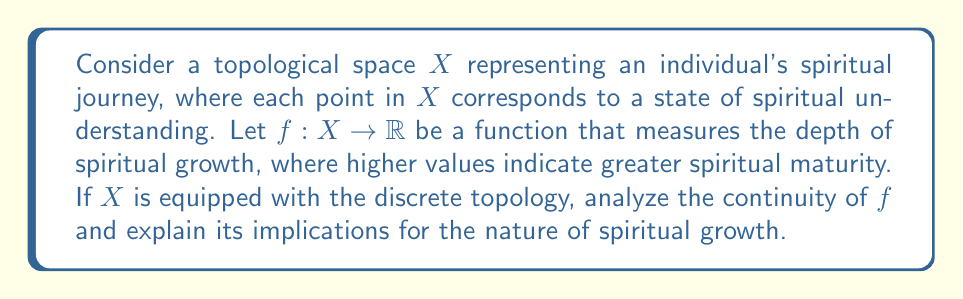Provide a solution to this math problem. To analyze this problem, let's break it down into steps:

1) First, recall that in a discrete topology, every subset of $X$ is open. This means that for any point $x \in X$, the set $\{x\}$ is open.

2) For a function to be continuous in the topological sense, the preimage of any open set in the codomain must be open in the domain.

3) In this case, $f: X \to \mathbb{R}$, where $X$ has the discrete topology and $\mathbb{R}$ has the standard topology.

4) Consider any open set $U \subset \mathbb{R}$. The preimage $f^{-1}(U)$ is a subset of $X$.

5) Since $X$ has the discrete topology, any subset of $X$ is open by definition, including $f^{-1}(U)$.

6) This means that for any open set $U$ in $\mathbb{R}$, its preimage under $f$ is open in $X$.

7) Therefore, $f$ is continuous for any function $f: X \to \mathbb{R}$ when $X$ has the discrete topology.

Implications for spiritual growth:

a) The continuity of $f$ in this topology suggests that spiritual growth can be viewed as a series of distinct, quantized states rather than a smooth, continuous progression.

b) Each point in $X$ represents a unique spiritual state, and the transition between states is "jumplike" rather than gradual.

c) This aligns with the perspective that spiritual growth often occurs through discrete moments of insight or revelation, rather than a continuous, smooth progression.

d) The discrete topology also implies that each spiritual state is "isolated" from others, emphasizing the uniqueness of each individual's spiritual journey.

e) However, this model may not capture the felt experience of gradual spiritual development over time, highlighting the limitations of using discrete topological models for continuous-feeling processes.
Answer: The function $f$ is continuous for any $f: X \to \mathbb{R}$ when $X$ has the discrete topology. This implies that spiritual growth, modeled topologically, can be understood as a series of distinct states rather than a continuous progression, aligning with the notion of spiritual growth through discrete moments of insight or revelation. 